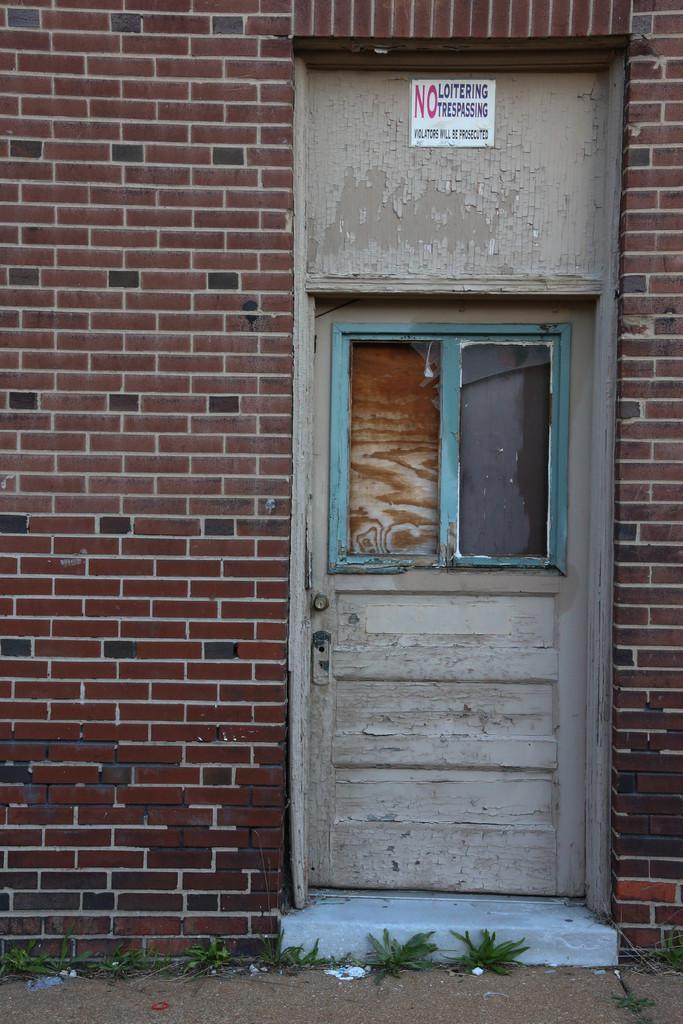Please provide a concise description of this image. In this image in the center there is one house and door and a window, at the bottom there is sand and grass. 